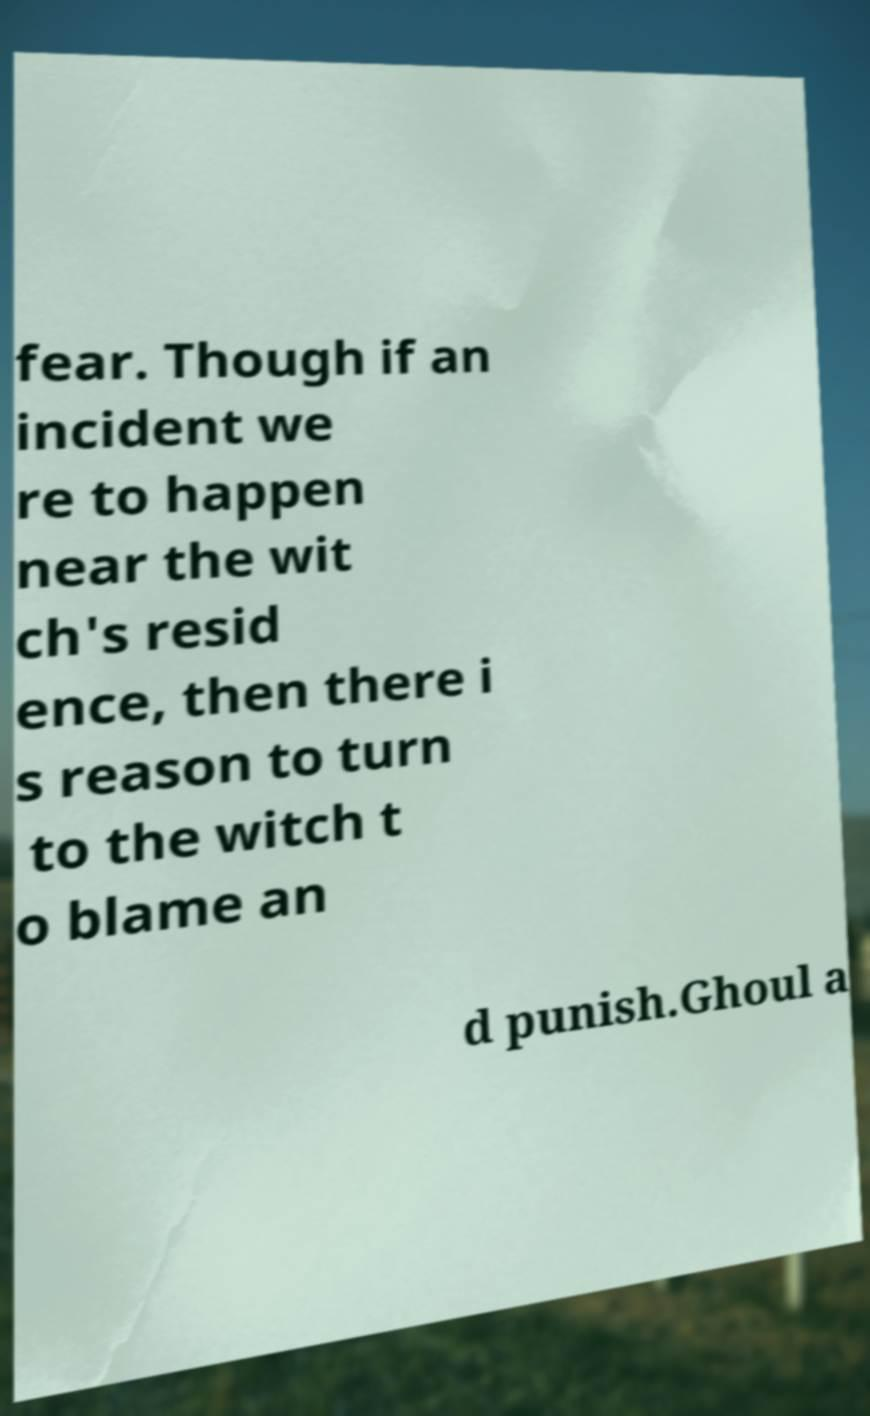Can you read and provide the text displayed in the image?This photo seems to have some interesting text. Can you extract and type it out for me? fear. Though if an incident we re to happen near the wit ch's resid ence, then there i s reason to turn to the witch t o blame an d punish.Ghoul a 